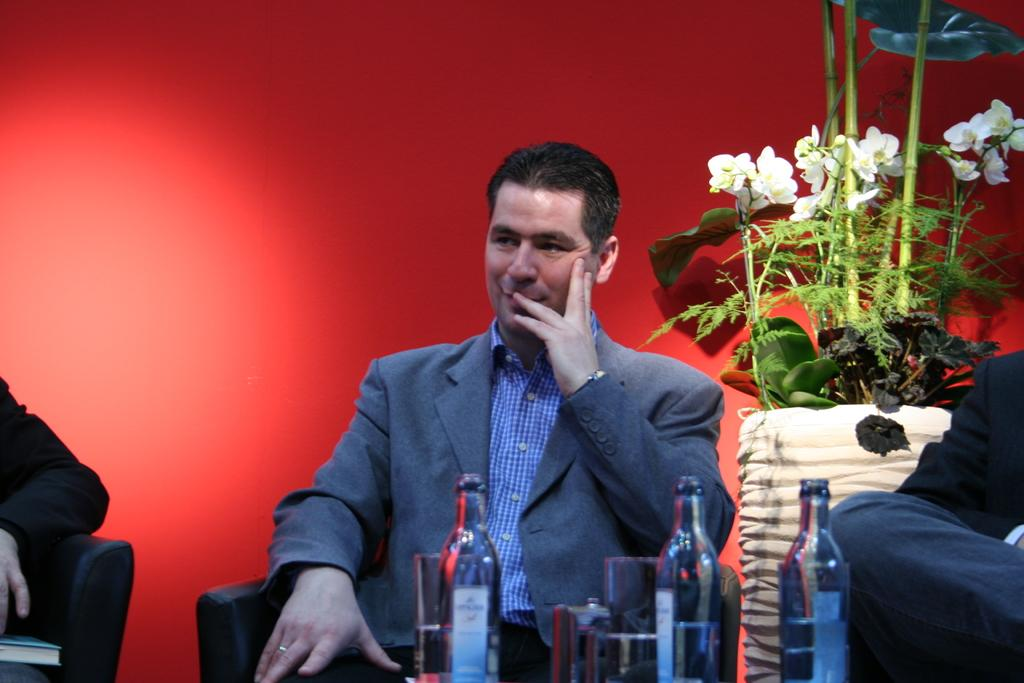Who or what is the main subject in the image? There is a person in the image. What is the person wearing? The person is wearing a coat. What is the person doing in the image? The person is sitting on a chair. What objects can be seen in the foreground of the image? There are bottles and glasses in the foreground of the image. Where is the plant vase located in the image? The plant vase is on the right side of the image. What type of stick is being used to hold up the cable in the image? There is no stick or cable present in the image. 